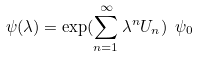Convert formula to latex. <formula><loc_0><loc_0><loc_500><loc_500>\psi ( \lambda ) = \exp ( \sum _ { n = 1 } ^ { \infty } \lambda ^ { n } U _ { n } ) \ \psi _ { 0 }</formula> 